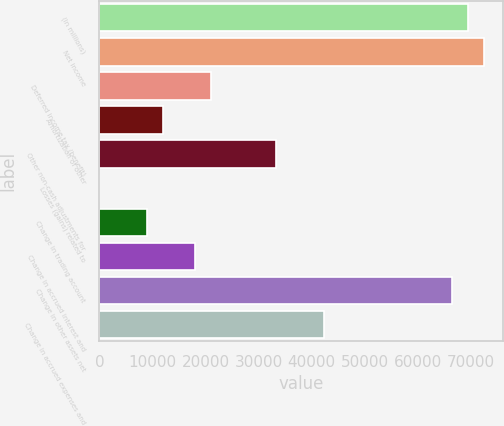Convert chart to OTSL. <chart><loc_0><loc_0><loc_500><loc_500><bar_chart><fcel>(In millions)<fcel>Net income<fcel>Deferred income tax (benefit)<fcel>Amortization of other<fcel>Other non-cash adjustments for<fcel>Losses (gains) related to<fcel>Change in trading account<fcel>Change in accrued interest and<fcel>Change in other assets net<fcel>Change in accrued expenses and<nl><fcel>69363.5<fcel>72379<fcel>21115.5<fcel>12069<fcel>33177.5<fcel>7<fcel>9053.5<fcel>18100<fcel>66348<fcel>42224<nl></chart> 